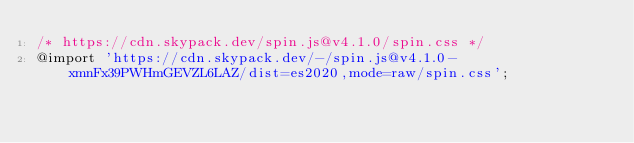<code> <loc_0><loc_0><loc_500><loc_500><_CSS_>/* https://cdn.skypack.dev/spin.js@v4.1.0/spin.css */
@import 'https://cdn.skypack.dev/-/spin.js@v4.1.0-xmnFx39PWHmGEVZL6LAZ/dist=es2020,mode=raw/spin.css';
</code> 